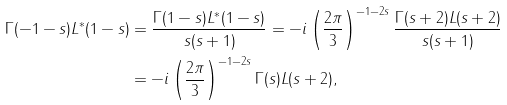Convert formula to latex. <formula><loc_0><loc_0><loc_500><loc_500>\Gamma ( - 1 - s ) L ^ { \ast } ( 1 - s ) & = \frac { \Gamma ( 1 - s ) L ^ { \ast } ( 1 - s ) } { s ( s + 1 ) } = - i \left ( \frac { 2 \pi } 3 \right ) ^ { - 1 - 2 s } \frac { \Gamma ( s + 2 ) L ( s + 2 ) } { s ( s + 1 ) } \\ & = - i \left ( \frac { 2 \pi } 3 \right ) ^ { - 1 - 2 s } \Gamma ( s ) L ( s + 2 ) ,</formula> 